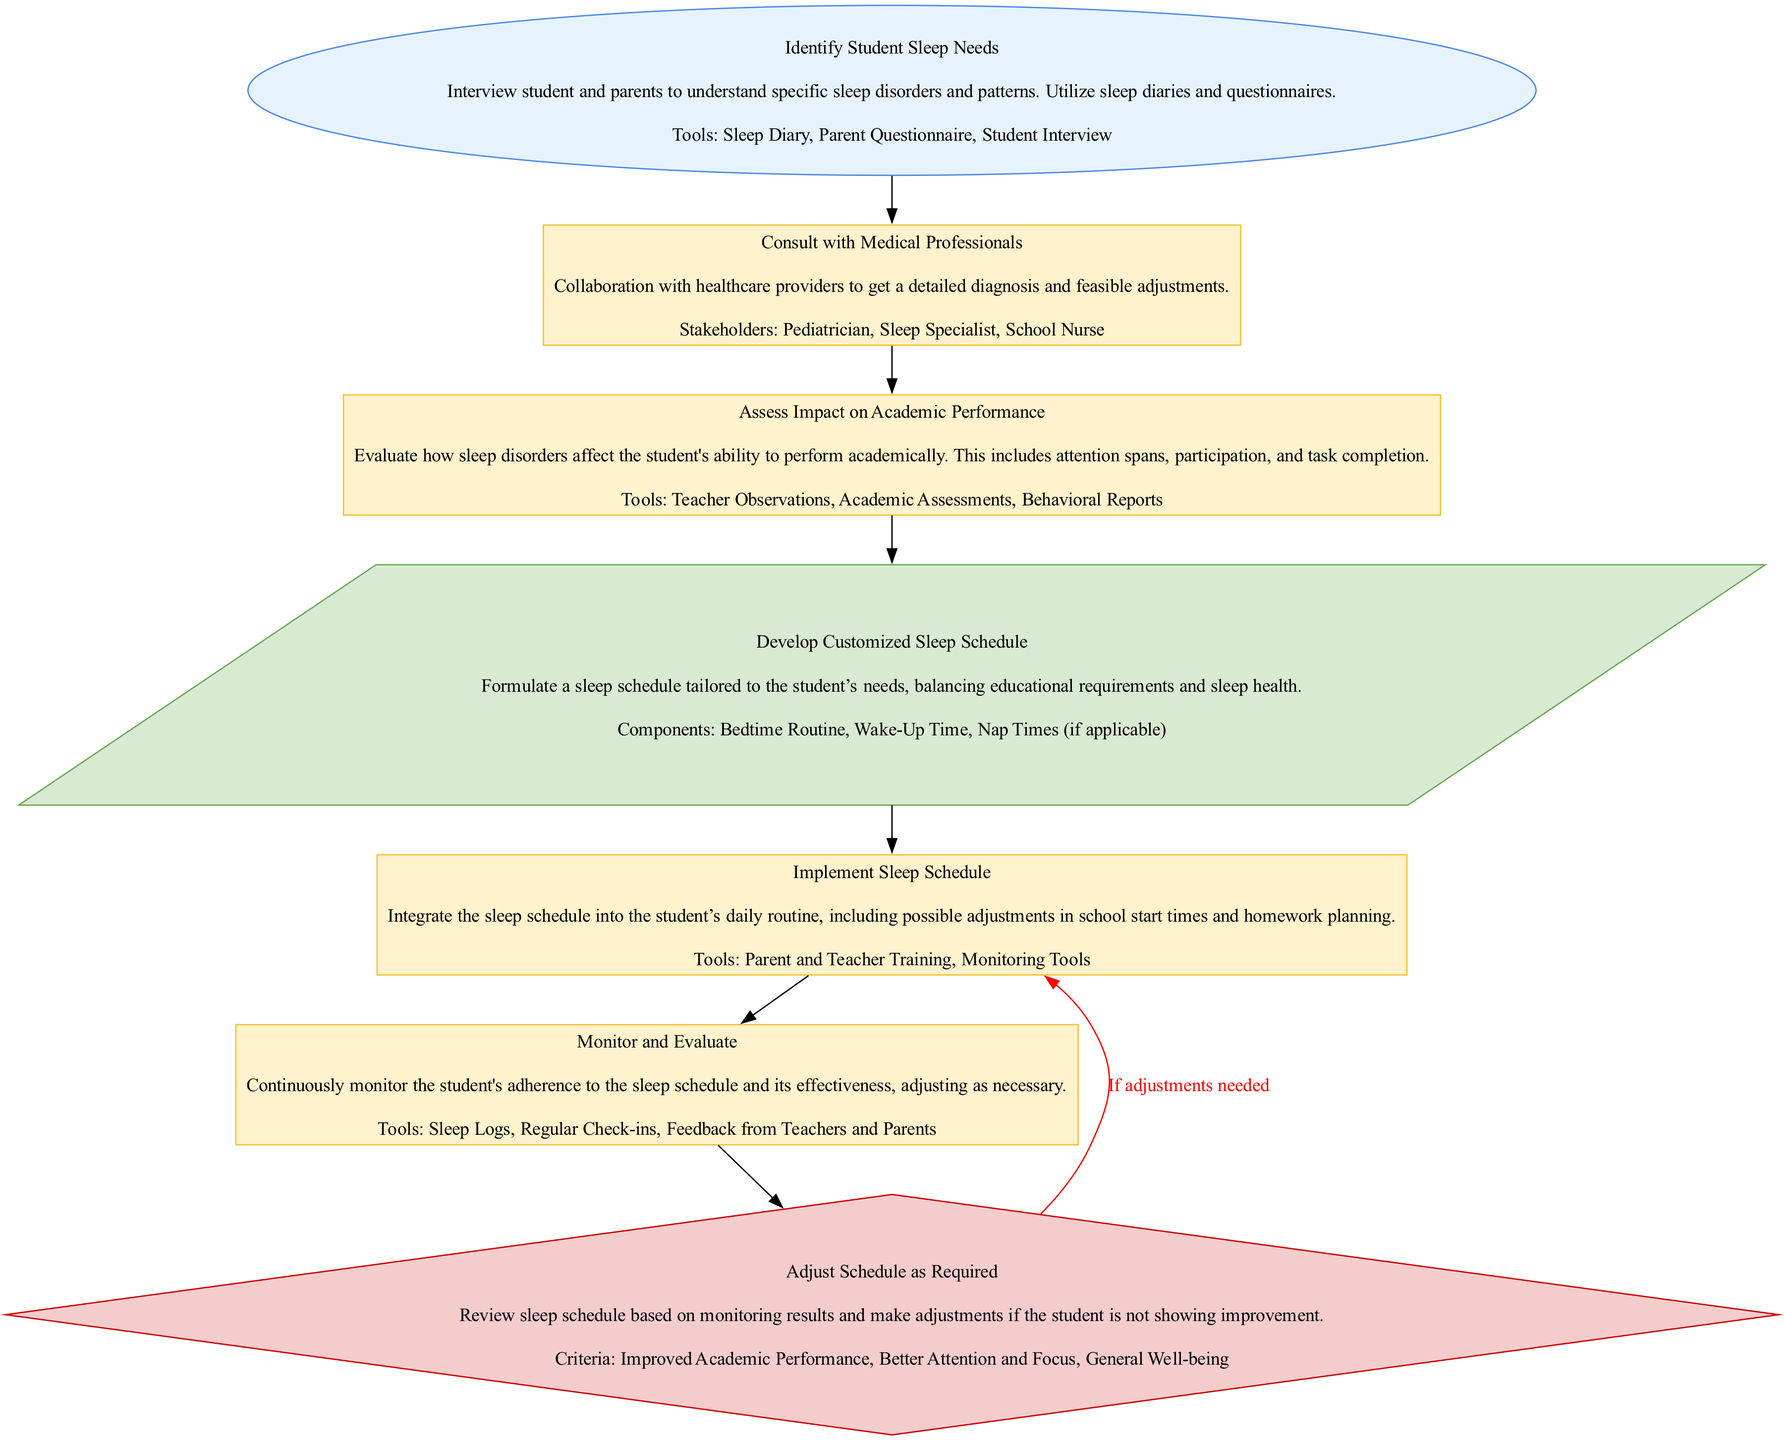What is the first step in the flowchart? The first node in the flowchart is "Identify Student Sleep Needs," which indicates that this is the initial step in the process.
Answer: Identify Student Sleep Needs How many process nodes are there in the diagram? The process nodes in the diagram are "Consult with Medical Professionals," "Assess Impact on Academic Performance," "Implement Sleep Schedule," and "Monitor and Evaluate." This totals to four process nodes.
Answer: Four What follows after the "Identify Student Sleep Needs" node? After "Identify Student Sleep Needs," the next step is "Consult with Medical Professionals," indicating the flow from understanding needs to collaboration with healthcare providers.
Answer: Consult with Medical Professionals What is the last output of the flowchart? The last output node is "Develop Customized Sleep Schedule," which indicates the intended result at the end of the process sequence.
Answer: Develop Customized Sleep Schedule What happens if adjustments are needed according to the flowchart? If adjustments are required, the process loops back to "Implement Sleep Schedule," suggesting that changes will be made and the schedule will be reapplied.
Answer: Implement Sleep Schedule What is the main purpose of the "Monitor and Evaluate" step? The purpose of this step is to continue monitoring the student’s adherence to the schedule and evaluate its effectiveness, leading to necessary adjustments if required.
Answer: Continuously monitor Which stakeholders are involved in the "Consult with Medical Professionals" process? The stakeholders mentioned in this step include "Pediatrician," "Sleep Specialist," and "School Nurse," indicating collaboration during this phase.
Answer: Pediatrician, Sleep Specialist, School Nurse What criteria are used to determine if the "Adjust Schedule as Required" node should be activated? The criteria listed are "Improved Academic Performance," "Better Attention and Focus," and "General Well-being," which will be evaluated to decide on schedule adjustments.
Answer: Improved Academic Performance, Better Attention and Focus, General Well-being 